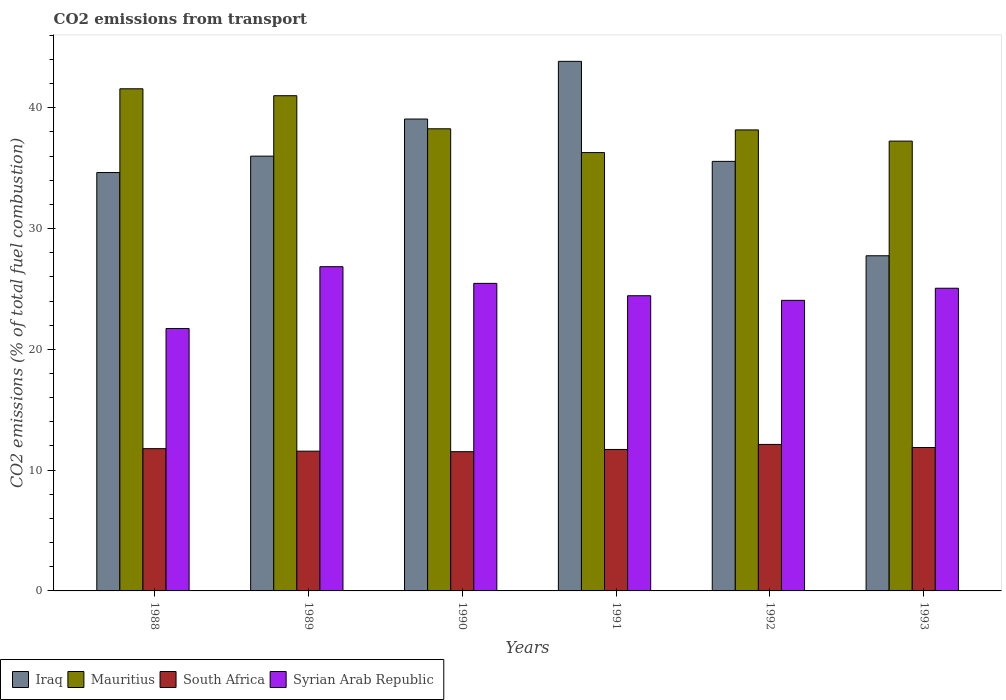How many bars are there on the 1st tick from the left?
Your answer should be very brief. 4. How many bars are there on the 2nd tick from the right?
Make the answer very short. 4. In how many cases, is the number of bars for a given year not equal to the number of legend labels?
Keep it short and to the point. 0. What is the total CO2 emitted in Mauritius in 1992?
Offer a very short reply. 38.17. Across all years, what is the maximum total CO2 emitted in Syrian Arab Republic?
Keep it short and to the point. 26.84. Across all years, what is the minimum total CO2 emitted in South Africa?
Your response must be concise. 11.53. What is the total total CO2 emitted in Iraq in the graph?
Offer a very short reply. 216.86. What is the difference between the total CO2 emitted in Mauritius in 1990 and that in 1991?
Keep it short and to the point. 1.97. What is the difference between the total CO2 emitted in Syrian Arab Republic in 1988 and the total CO2 emitted in Iraq in 1993?
Make the answer very short. -6.02. What is the average total CO2 emitted in Mauritius per year?
Your response must be concise. 38.76. In the year 1993, what is the difference between the total CO2 emitted in Mauritius and total CO2 emitted in South Africa?
Your response must be concise. 25.37. In how many years, is the total CO2 emitted in Mauritius greater than 30?
Make the answer very short. 6. What is the ratio of the total CO2 emitted in South Africa in 1989 to that in 1990?
Your answer should be compact. 1. Is the total CO2 emitted in Syrian Arab Republic in 1989 less than that in 1990?
Ensure brevity in your answer.  No. What is the difference between the highest and the second highest total CO2 emitted in Iraq?
Give a very brief answer. 4.78. What is the difference between the highest and the lowest total CO2 emitted in Iraq?
Your answer should be compact. 16.1. In how many years, is the total CO2 emitted in South Africa greater than the average total CO2 emitted in South Africa taken over all years?
Provide a short and direct response. 3. Is the sum of the total CO2 emitted in Mauritius in 1990 and 1991 greater than the maximum total CO2 emitted in Syrian Arab Republic across all years?
Offer a very short reply. Yes. What does the 4th bar from the left in 1988 represents?
Offer a terse response. Syrian Arab Republic. What does the 3rd bar from the right in 1991 represents?
Offer a terse response. Mauritius. Is it the case that in every year, the sum of the total CO2 emitted in South Africa and total CO2 emitted in Syrian Arab Republic is greater than the total CO2 emitted in Iraq?
Offer a very short reply. No. How many bars are there?
Your response must be concise. 24. How many years are there in the graph?
Offer a terse response. 6. What is the difference between two consecutive major ticks on the Y-axis?
Your answer should be compact. 10. Does the graph contain grids?
Keep it short and to the point. No. How many legend labels are there?
Give a very brief answer. 4. What is the title of the graph?
Your response must be concise. CO2 emissions from transport. What is the label or title of the Y-axis?
Provide a short and direct response. CO2 emissions (% of total fuel combustion). What is the CO2 emissions (% of total fuel combustion) of Iraq in 1988?
Your response must be concise. 34.64. What is the CO2 emissions (% of total fuel combustion) in Mauritius in 1988?
Your answer should be very brief. 41.57. What is the CO2 emissions (% of total fuel combustion) of South Africa in 1988?
Your answer should be compact. 11.78. What is the CO2 emissions (% of total fuel combustion) in Syrian Arab Republic in 1988?
Give a very brief answer. 21.73. What is the CO2 emissions (% of total fuel combustion) of Iraq in 1989?
Ensure brevity in your answer.  36. What is the CO2 emissions (% of total fuel combustion) in Mauritius in 1989?
Provide a succinct answer. 41. What is the CO2 emissions (% of total fuel combustion) of South Africa in 1989?
Keep it short and to the point. 11.57. What is the CO2 emissions (% of total fuel combustion) of Syrian Arab Republic in 1989?
Your answer should be compact. 26.84. What is the CO2 emissions (% of total fuel combustion) of Iraq in 1990?
Your answer should be compact. 39.07. What is the CO2 emissions (% of total fuel combustion) in Mauritius in 1990?
Provide a succinct answer. 38.26. What is the CO2 emissions (% of total fuel combustion) in South Africa in 1990?
Give a very brief answer. 11.53. What is the CO2 emissions (% of total fuel combustion) in Syrian Arab Republic in 1990?
Provide a succinct answer. 25.46. What is the CO2 emissions (% of total fuel combustion) in Iraq in 1991?
Your response must be concise. 43.84. What is the CO2 emissions (% of total fuel combustion) of Mauritius in 1991?
Offer a very short reply. 36.29. What is the CO2 emissions (% of total fuel combustion) in South Africa in 1991?
Provide a succinct answer. 11.71. What is the CO2 emissions (% of total fuel combustion) in Syrian Arab Republic in 1991?
Your response must be concise. 24.44. What is the CO2 emissions (% of total fuel combustion) in Iraq in 1992?
Make the answer very short. 35.56. What is the CO2 emissions (% of total fuel combustion) of Mauritius in 1992?
Your answer should be very brief. 38.17. What is the CO2 emissions (% of total fuel combustion) in South Africa in 1992?
Offer a very short reply. 12.13. What is the CO2 emissions (% of total fuel combustion) of Syrian Arab Republic in 1992?
Your answer should be compact. 24.06. What is the CO2 emissions (% of total fuel combustion) in Iraq in 1993?
Make the answer very short. 27.75. What is the CO2 emissions (% of total fuel combustion) in Mauritius in 1993?
Your answer should be compact. 37.24. What is the CO2 emissions (% of total fuel combustion) in South Africa in 1993?
Ensure brevity in your answer.  11.87. What is the CO2 emissions (% of total fuel combustion) in Syrian Arab Republic in 1993?
Make the answer very short. 25.06. Across all years, what is the maximum CO2 emissions (% of total fuel combustion) in Iraq?
Provide a succinct answer. 43.84. Across all years, what is the maximum CO2 emissions (% of total fuel combustion) of Mauritius?
Provide a short and direct response. 41.57. Across all years, what is the maximum CO2 emissions (% of total fuel combustion) in South Africa?
Offer a very short reply. 12.13. Across all years, what is the maximum CO2 emissions (% of total fuel combustion) of Syrian Arab Republic?
Your response must be concise. 26.84. Across all years, what is the minimum CO2 emissions (% of total fuel combustion) of Iraq?
Your response must be concise. 27.75. Across all years, what is the minimum CO2 emissions (% of total fuel combustion) of Mauritius?
Offer a terse response. 36.29. Across all years, what is the minimum CO2 emissions (% of total fuel combustion) in South Africa?
Offer a very short reply. 11.53. Across all years, what is the minimum CO2 emissions (% of total fuel combustion) of Syrian Arab Republic?
Provide a short and direct response. 21.73. What is the total CO2 emissions (% of total fuel combustion) of Iraq in the graph?
Your response must be concise. 216.86. What is the total CO2 emissions (% of total fuel combustion) of Mauritius in the graph?
Offer a very short reply. 232.53. What is the total CO2 emissions (% of total fuel combustion) of South Africa in the graph?
Your answer should be very brief. 70.59. What is the total CO2 emissions (% of total fuel combustion) in Syrian Arab Republic in the graph?
Offer a very short reply. 147.59. What is the difference between the CO2 emissions (% of total fuel combustion) of Iraq in 1988 and that in 1989?
Keep it short and to the point. -1.36. What is the difference between the CO2 emissions (% of total fuel combustion) in Mauritius in 1988 and that in 1989?
Your response must be concise. 0.57. What is the difference between the CO2 emissions (% of total fuel combustion) in South Africa in 1988 and that in 1989?
Give a very brief answer. 0.21. What is the difference between the CO2 emissions (% of total fuel combustion) in Syrian Arab Republic in 1988 and that in 1989?
Make the answer very short. -5.12. What is the difference between the CO2 emissions (% of total fuel combustion) in Iraq in 1988 and that in 1990?
Your response must be concise. -4.43. What is the difference between the CO2 emissions (% of total fuel combustion) of Mauritius in 1988 and that in 1990?
Give a very brief answer. 3.31. What is the difference between the CO2 emissions (% of total fuel combustion) of South Africa in 1988 and that in 1990?
Keep it short and to the point. 0.25. What is the difference between the CO2 emissions (% of total fuel combustion) in Syrian Arab Republic in 1988 and that in 1990?
Make the answer very short. -3.74. What is the difference between the CO2 emissions (% of total fuel combustion) in Iraq in 1988 and that in 1991?
Your answer should be very brief. -9.2. What is the difference between the CO2 emissions (% of total fuel combustion) of Mauritius in 1988 and that in 1991?
Your answer should be compact. 5.28. What is the difference between the CO2 emissions (% of total fuel combustion) in South Africa in 1988 and that in 1991?
Provide a short and direct response. 0.07. What is the difference between the CO2 emissions (% of total fuel combustion) in Syrian Arab Republic in 1988 and that in 1991?
Ensure brevity in your answer.  -2.71. What is the difference between the CO2 emissions (% of total fuel combustion) in Iraq in 1988 and that in 1992?
Ensure brevity in your answer.  -0.92. What is the difference between the CO2 emissions (% of total fuel combustion) in Mauritius in 1988 and that in 1992?
Keep it short and to the point. 3.41. What is the difference between the CO2 emissions (% of total fuel combustion) of South Africa in 1988 and that in 1992?
Provide a succinct answer. -0.35. What is the difference between the CO2 emissions (% of total fuel combustion) in Syrian Arab Republic in 1988 and that in 1992?
Offer a very short reply. -2.33. What is the difference between the CO2 emissions (% of total fuel combustion) of Iraq in 1988 and that in 1993?
Your answer should be very brief. 6.89. What is the difference between the CO2 emissions (% of total fuel combustion) in Mauritius in 1988 and that in 1993?
Give a very brief answer. 4.33. What is the difference between the CO2 emissions (% of total fuel combustion) of South Africa in 1988 and that in 1993?
Your response must be concise. -0.09. What is the difference between the CO2 emissions (% of total fuel combustion) of Syrian Arab Republic in 1988 and that in 1993?
Provide a short and direct response. -3.33. What is the difference between the CO2 emissions (% of total fuel combustion) of Iraq in 1989 and that in 1990?
Your response must be concise. -3.07. What is the difference between the CO2 emissions (% of total fuel combustion) of Mauritius in 1989 and that in 1990?
Your answer should be compact. 2.74. What is the difference between the CO2 emissions (% of total fuel combustion) of South Africa in 1989 and that in 1990?
Your answer should be very brief. 0.04. What is the difference between the CO2 emissions (% of total fuel combustion) in Syrian Arab Republic in 1989 and that in 1990?
Your answer should be very brief. 1.38. What is the difference between the CO2 emissions (% of total fuel combustion) of Iraq in 1989 and that in 1991?
Ensure brevity in your answer.  -7.85. What is the difference between the CO2 emissions (% of total fuel combustion) of Mauritius in 1989 and that in 1991?
Offer a very short reply. 4.71. What is the difference between the CO2 emissions (% of total fuel combustion) of South Africa in 1989 and that in 1991?
Your answer should be very brief. -0.14. What is the difference between the CO2 emissions (% of total fuel combustion) in Syrian Arab Republic in 1989 and that in 1991?
Provide a succinct answer. 2.4. What is the difference between the CO2 emissions (% of total fuel combustion) of Iraq in 1989 and that in 1992?
Provide a succinct answer. 0.43. What is the difference between the CO2 emissions (% of total fuel combustion) of Mauritius in 1989 and that in 1992?
Offer a terse response. 2.83. What is the difference between the CO2 emissions (% of total fuel combustion) in South Africa in 1989 and that in 1992?
Ensure brevity in your answer.  -0.56. What is the difference between the CO2 emissions (% of total fuel combustion) in Syrian Arab Republic in 1989 and that in 1992?
Your answer should be compact. 2.79. What is the difference between the CO2 emissions (% of total fuel combustion) of Iraq in 1989 and that in 1993?
Provide a short and direct response. 8.25. What is the difference between the CO2 emissions (% of total fuel combustion) in Mauritius in 1989 and that in 1993?
Provide a short and direct response. 3.76. What is the difference between the CO2 emissions (% of total fuel combustion) of South Africa in 1989 and that in 1993?
Offer a terse response. -0.3. What is the difference between the CO2 emissions (% of total fuel combustion) of Syrian Arab Republic in 1989 and that in 1993?
Ensure brevity in your answer.  1.78. What is the difference between the CO2 emissions (% of total fuel combustion) of Iraq in 1990 and that in 1991?
Give a very brief answer. -4.78. What is the difference between the CO2 emissions (% of total fuel combustion) of Mauritius in 1990 and that in 1991?
Provide a short and direct response. 1.97. What is the difference between the CO2 emissions (% of total fuel combustion) of South Africa in 1990 and that in 1991?
Give a very brief answer. -0.18. What is the difference between the CO2 emissions (% of total fuel combustion) in Syrian Arab Republic in 1990 and that in 1991?
Give a very brief answer. 1.02. What is the difference between the CO2 emissions (% of total fuel combustion) in Iraq in 1990 and that in 1992?
Your answer should be compact. 3.5. What is the difference between the CO2 emissions (% of total fuel combustion) in Mauritius in 1990 and that in 1992?
Offer a terse response. 0.09. What is the difference between the CO2 emissions (% of total fuel combustion) in South Africa in 1990 and that in 1992?
Keep it short and to the point. -0.6. What is the difference between the CO2 emissions (% of total fuel combustion) in Syrian Arab Republic in 1990 and that in 1992?
Offer a very short reply. 1.4. What is the difference between the CO2 emissions (% of total fuel combustion) in Iraq in 1990 and that in 1993?
Your response must be concise. 11.32. What is the difference between the CO2 emissions (% of total fuel combustion) in Mauritius in 1990 and that in 1993?
Keep it short and to the point. 1.02. What is the difference between the CO2 emissions (% of total fuel combustion) of South Africa in 1990 and that in 1993?
Make the answer very short. -0.35. What is the difference between the CO2 emissions (% of total fuel combustion) in Syrian Arab Republic in 1990 and that in 1993?
Offer a terse response. 0.4. What is the difference between the CO2 emissions (% of total fuel combustion) in Iraq in 1991 and that in 1992?
Provide a short and direct response. 8.28. What is the difference between the CO2 emissions (% of total fuel combustion) in Mauritius in 1991 and that in 1992?
Your answer should be compact. -1.88. What is the difference between the CO2 emissions (% of total fuel combustion) in South Africa in 1991 and that in 1992?
Your answer should be very brief. -0.42. What is the difference between the CO2 emissions (% of total fuel combustion) in Syrian Arab Republic in 1991 and that in 1992?
Offer a very short reply. 0.38. What is the difference between the CO2 emissions (% of total fuel combustion) of Iraq in 1991 and that in 1993?
Ensure brevity in your answer.  16.1. What is the difference between the CO2 emissions (% of total fuel combustion) of Mauritius in 1991 and that in 1993?
Keep it short and to the point. -0.95. What is the difference between the CO2 emissions (% of total fuel combustion) in South Africa in 1991 and that in 1993?
Provide a short and direct response. -0.16. What is the difference between the CO2 emissions (% of total fuel combustion) of Syrian Arab Republic in 1991 and that in 1993?
Provide a short and direct response. -0.62. What is the difference between the CO2 emissions (% of total fuel combustion) in Iraq in 1992 and that in 1993?
Your answer should be very brief. 7.82. What is the difference between the CO2 emissions (% of total fuel combustion) in Mauritius in 1992 and that in 1993?
Give a very brief answer. 0.93. What is the difference between the CO2 emissions (% of total fuel combustion) in South Africa in 1992 and that in 1993?
Provide a succinct answer. 0.25. What is the difference between the CO2 emissions (% of total fuel combustion) of Syrian Arab Republic in 1992 and that in 1993?
Your answer should be very brief. -1. What is the difference between the CO2 emissions (% of total fuel combustion) of Iraq in 1988 and the CO2 emissions (% of total fuel combustion) of Mauritius in 1989?
Give a very brief answer. -6.36. What is the difference between the CO2 emissions (% of total fuel combustion) of Iraq in 1988 and the CO2 emissions (% of total fuel combustion) of South Africa in 1989?
Make the answer very short. 23.07. What is the difference between the CO2 emissions (% of total fuel combustion) in Iraq in 1988 and the CO2 emissions (% of total fuel combustion) in Syrian Arab Republic in 1989?
Your answer should be compact. 7.8. What is the difference between the CO2 emissions (% of total fuel combustion) of Mauritius in 1988 and the CO2 emissions (% of total fuel combustion) of South Africa in 1989?
Offer a terse response. 30. What is the difference between the CO2 emissions (% of total fuel combustion) of Mauritius in 1988 and the CO2 emissions (% of total fuel combustion) of Syrian Arab Republic in 1989?
Your answer should be compact. 14.73. What is the difference between the CO2 emissions (% of total fuel combustion) in South Africa in 1988 and the CO2 emissions (% of total fuel combustion) in Syrian Arab Republic in 1989?
Offer a terse response. -15.06. What is the difference between the CO2 emissions (% of total fuel combustion) of Iraq in 1988 and the CO2 emissions (% of total fuel combustion) of Mauritius in 1990?
Provide a succinct answer. -3.62. What is the difference between the CO2 emissions (% of total fuel combustion) of Iraq in 1988 and the CO2 emissions (% of total fuel combustion) of South Africa in 1990?
Offer a terse response. 23.11. What is the difference between the CO2 emissions (% of total fuel combustion) in Iraq in 1988 and the CO2 emissions (% of total fuel combustion) in Syrian Arab Republic in 1990?
Your response must be concise. 9.18. What is the difference between the CO2 emissions (% of total fuel combustion) of Mauritius in 1988 and the CO2 emissions (% of total fuel combustion) of South Africa in 1990?
Make the answer very short. 30.05. What is the difference between the CO2 emissions (% of total fuel combustion) in Mauritius in 1988 and the CO2 emissions (% of total fuel combustion) in Syrian Arab Republic in 1990?
Offer a terse response. 16.11. What is the difference between the CO2 emissions (% of total fuel combustion) of South Africa in 1988 and the CO2 emissions (% of total fuel combustion) of Syrian Arab Republic in 1990?
Give a very brief answer. -13.68. What is the difference between the CO2 emissions (% of total fuel combustion) in Iraq in 1988 and the CO2 emissions (% of total fuel combustion) in Mauritius in 1991?
Make the answer very short. -1.65. What is the difference between the CO2 emissions (% of total fuel combustion) in Iraq in 1988 and the CO2 emissions (% of total fuel combustion) in South Africa in 1991?
Offer a very short reply. 22.93. What is the difference between the CO2 emissions (% of total fuel combustion) of Iraq in 1988 and the CO2 emissions (% of total fuel combustion) of Syrian Arab Republic in 1991?
Offer a very short reply. 10.2. What is the difference between the CO2 emissions (% of total fuel combustion) in Mauritius in 1988 and the CO2 emissions (% of total fuel combustion) in South Africa in 1991?
Your response must be concise. 29.86. What is the difference between the CO2 emissions (% of total fuel combustion) of Mauritius in 1988 and the CO2 emissions (% of total fuel combustion) of Syrian Arab Republic in 1991?
Give a very brief answer. 17.13. What is the difference between the CO2 emissions (% of total fuel combustion) of South Africa in 1988 and the CO2 emissions (% of total fuel combustion) of Syrian Arab Republic in 1991?
Make the answer very short. -12.66. What is the difference between the CO2 emissions (% of total fuel combustion) in Iraq in 1988 and the CO2 emissions (% of total fuel combustion) in Mauritius in 1992?
Give a very brief answer. -3.53. What is the difference between the CO2 emissions (% of total fuel combustion) in Iraq in 1988 and the CO2 emissions (% of total fuel combustion) in South Africa in 1992?
Offer a very short reply. 22.51. What is the difference between the CO2 emissions (% of total fuel combustion) in Iraq in 1988 and the CO2 emissions (% of total fuel combustion) in Syrian Arab Republic in 1992?
Offer a very short reply. 10.58. What is the difference between the CO2 emissions (% of total fuel combustion) in Mauritius in 1988 and the CO2 emissions (% of total fuel combustion) in South Africa in 1992?
Make the answer very short. 29.44. What is the difference between the CO2 emissions (% of total fuel combustion) of Mauritius in 1988 and the CO2 emissions (% of total fuel combustion) of Syrian Arab Republic in 1992?
Keep it short and to the point. 17.52. What is the difference between the CO2 emissions (% of total fuel combustion) in South Africa in 1988 and the CO2 emissions (% of total fuel combustion) in Syrian Arab Republic in 1992?
Your answer should be very brief. -12.28. What is the difference between the CO2 emissions (% of total fuel combustion) of Iraq in 1988 and the CO2 emissions (% of total fuel combustion) of Mauritius in 1993?
Make the answer very short. -2.6. What is the difference between the CO2 emissions (% of total fuel combustion) in Iraq in 1988 and the CO2 emissions (% of total fuel combustion) in South Africa in 1993?
Give a very brief answer. 22.77. What is the difference between the CO2 emissions (% of total fuel combustion) of Iraq in 1988 and the CO2 emissions (% of total fuel combustion) of Syrian Arab Republic in 1993?
Give a very brief answer. 9.58. What is the difference between the CO2 emissions (% of total fuel combustion) in Mauritius in 1988 and the CO2 emissions (% of total fuel combustion) in South Africa in 1993?
Offer a very short reply. 29.7. What is the difference between the CO2 emissions (% of total fuel combustion) of Mauritius in 1988 and the CO2 emissions (% of total fuel combustion) of Syrian Arab Republic in 1993?
Give a very brief answer. 16.51. What is the difference between the CO2 emissions (% of total fuel combustion) of South Africa in 1988 and the CO2 emissions (% of total fuel combustion) of Syrian Arab Republic in 1993?
Offer a terse response. -13.28. What is the difference between the CO2 emissions (% of total fuel combustion) of Iraq in 1989 and the CO2 emissions (% of total fuel combustion) of Mauritius in 1990?
Your answer should be very brief. -2.27. What is the difference between the CO2 emissions (% of total fuel combustion) of Iraq in 1989 and the CO2 emissions (% of total fuel combustion) of South Africa in 1990?
Offer a terse response. 24.47. What is the difference between the CO2 emissions (% of total fuel combustion) of Iraq in 1989 and the CO2 emissions (% of total fuel combustion) of Syrian Arab Republic in 1990?
Your response must be concise. 10.53. What is the difference between the CO2 emissions (% of total fuel combustion) in Mauritius in 1989 and the CO2 emissions (% of total fuel combustion) in South Africa in 1990?
Provide a short and direct response. 29.47. What is the difference between the CO2 emissions (% of total fuel combustion) in Mauritius in 1989 and the CO2 emissions (% of total fuel combustion) in Syrian Arab Republic in 1990?
Your response must be concise. 15.54. What is the difference between the CO2 emissions (% of total fuel combustion) of South Africa in 1989 and the CO2 emissions (% of total fuel combustion) of Syrian Arab Republic in 1990?
Offer a very short reply. -13.89. What is the difference between the CO2 emissions (% of total fuel combustion) in Iraq in 1989 and the CO2 emissions (% of total fuel combustion) in Mauritius in 1991?
Provide a succinct answer. -0.29. What is the difference between the CO2 emissions (% of total fuel combustion) of Iraq in 1989 and the CO2 emissions (% of total fuel combustion) of South Africa in 1991?
Offer a very short reply. 24.28. What is the difference between the CO2 emissions (% of total fuel combustion) of Iraq in 1989 and the CO2 emissions (% of total fuel combustion) of Syrian Arab Republic in 1991?
Your response must be concise. 11.56. What is the difference between the CO2 emissions (% of total fuel combustion) in Mauritius in 1989 and the CO2 emissions (% of total fuel combustion) in South Africa in 1991?
Your response must be concise. 29.29. What is the difference between the CO2 emissions (% of total fuel combustion) in Mauritius in 1989 and the CO2 emissions (% of total fuel combustion) in Syrian Arab Republic in 1991?
Provide a succinct answer. 16.56. What is the difference between the CO2 emissions (% of total fuel combustion) of South Africa in 1989 and the CO2 emissions (% of total fuel combustion) of Syrian Arab Republic in 1991?
Give a very brief answer. -12.87. What is the difference between the CO2 emissions (% of total fuel combustion) in Iraq in 1989 and the CO2 emissions (% of total fuel combustion) in Mauritius in 1992?
Provide a short and direct response. -2.17. What is the difference between the CO2 emissions (% of total fuel combustion) in Iraq in 1989 and the CO2 emissions (% of total fuel combustion) in South Africa in 1992?
Provide a short and direct response. 23.87. What is the difference between the CO2 emissions (% of total fuel combustion) of Iraq in 1989 and the CO2 emissions (% of total fuel combustion) of Syrian Arab Republic in 1992?
Provide a succinct answer. 11.94. What is the difference between the CO2 emissions (% of total fuel combustion) of Mauritius in 1989 and the CO2 emissions (% of total fuel combustion) of South Africa in 1992?
Ensure brevity in your answer.  28.87. What is the difference between the CO2 emissions (% of total fuel combustion) in Mauritius in 1989 and the CO2 emissions (% of total fuel combustion) in Syrian Arab Republic in 1992?
Give a very brief answer. 16.94. What is the difference between the CO2 emissions (% of total fuel combustion) of South Africa in 1989 and the CO2 emissions (% of total fuel combustion) of Syrian Arab Republic in 1992?
Your answer should be very brief. -12.49. What is the difference between the CO2 emissions (% of total fuel combustion) in Iraq in 1989 and the CO2 emissions (% of total fuel combustion) in Mauritius in 1993?
Offer a very short reply. -1.25. What is the difference between the CO2 emissions (% of total fuel combustion) of Iraq in 1989 and the CO2 emissions (% of total fuel combustion) of South Africa in 1993?
Your answer should be very brief. 24.12. What is the difference between the CO2 emissions (% of total fuel combustion) in Iraq in 1989 and the CO2 emissions (% of total fuel combustion) in Syrian Arab Republic in 1993?
Provide a succinct answer. 10.94. What is the difference between the CO2 emissions (% of total fuel combustion) in Mauritius in 1989 and the CO2 emissions (% of total fuel combustion) in South Africa in 1993?
Ensure brevity in your answer.  29.13. What is the difference between the CO2 emissions (% of total fuel combustion) in Mauritius in 1989 and the CO2 emissions (% of total fuel combustion) in Syrian Arab Republic in 1993?
Ensure brevity in your answer.  15.94. What is the difference between the CO2 emissions (% of total fuel combustion) of South Africa in 1989 and the CO2 emissions (% of total fuel combustion) of Syrian Arab Republic in 1993?
Offer a very short reply. -13.49. What is the difference between the CO2 emissions (% of total fuel combustion) of Iraq in 1990 and the CO2 emissions (% of total fuel combustion) of Mauritius in 1991?
Make the answer very short. 2.78. What is the difference between the CO2 emissions (% of total fuel combustion) in Iraq in 1990 and the CO2 emissions (% of total fuel combustion) in South Africa in 1991?
Your answer should be compact. 27.36. What is the difference between the CO2 emissions (% of total fuel combustion) of Iraq in 1990 and the CO2 emissions (% of total fuel combustion) of Syrian Arab Republic in 1991?
Give a very brief answer. 14.63. What is the difference between the CO2 emissions (% of total fuel combustion) of Mauritius in 1990 and the CO2 emissions (% of total fuel combustion) of South Africa in 1991?
Make the answer very short. 26.55. What is the difference between the CO2 emissions (% of total fuel combustion) in Mauritius in 1990 and the CO2 emissions (% of total fuel combustion) in Syrian Arab Republic in 1991?
Provide a succinct answer. 13.82. What is the difference between the CO2 emissions (% of total fuel combustion) in South Africa in 1990 and the CO2 emissions (% of total fuel combustion) in Syrian Arab Republic in 1991?
Your answer should be compact. -12.91. What is the difference between the CO2 emissions (% of total fuel combustion) in Iraq in 1990 and the CO2 emissions (% of total fuel combustion) in Mauritius in 1992?
Provide a short and direct response. 0.9. What is the difference between the CO2 emissions (% of total fuel combustion) of Iraq in 1990 and the CO2 emissions (% of total fuel combustion) of South Africa in 1992?
Your response must be concise. 26.94. What is the difference between the CO2 emissions (% of total fuel combustion) in Iraq in 1990 and the CO2 emissions (% of total fuel combustion) in Syrian Arab Republic in 1992?
Ensure brevity in your answer.  15.01. What is the difference between the CO2 emissions (% of total fuel combustion) in Mauritius in 1990 and the CO2 emissions (% of total fuel combustion) in South Africa in 1992?
Offer a terse response. 26.13. What is the difference between the CO2 emissions (% of total fuel combustion) of Mauritius in 1990 and the CO2 emissions (% of total fuel combustion) of Syrian Arab Republic in 1992?
Keep it short and to the point. 14.2. What is the difference between the CO2 emissions (% of total fuel combustion) of South Africa in 1990 and the CO2 emissions (% of total fuel combustion) of Syrian Arab Republic in 1992?
Your answer should be compact. -12.53. What is the difference between the CO2 emissions (% of total fuel combustion) of Iraq in 1990 and the CO2 emissions (% of total fuel combustion) of Mauritius in 1993?
Your response must be concise. 1.83. What is the difference between the CO2 emissions (% of total fuel combustion) of Iraq in 1990 and the CO2 emissions (% of total fuel combustion) of South Africa in 1993?
Offer a very short reply. 27.19. What is the difference between the CO2 emissions (% of total fuel combustion) of Iraq in 1990 and the CO2 emissions (% of total fuel combustion) of Syrian Arab Republic in 1993?
Keep it short and to the point. 14.01. What is the difference between the CO2 emissions (% of total fuel combustion) of Mauritius in 1990 and the CO2 emissions (% of total fuel combustion) of South Africa in 1993?
Provide a succinct answer. 26.39. What is the difference between the CO2 emissions (% of total fuel combustion) of Mauritius in 1990 and the CO2 emissions (% of total fuel combustion) of Syrian Arab Republic in 1993?
Provide a succinct answer. 13.2. What is the difference between the CO2 emissions (% of total fuel combustion) in South Africa in 1990 and the CO2 emissions (% of total fuel combustion) in Syrian Arab Republic in 1993?
Your answer should be compact. -13.53. What is the difference between the CO2 emissions (% of total fuel combustion) in Iraq in 1991 and the CO2 emissions (% of total fuel combustion) in Mauritius in 1992?
Offer a very short reply. 5.68. What is the difference between the CO2 emissions (% of total fuel combustion) in Iraq in 1991 and the CO2 emissions (% of total fuel combustion) in South Africa in 1992?
Give a very brief answer. 31.72. What is the difference between the CO2 emissions (% of total fuel combustion) of Iraq in 1991 and the CO2 emissions (% of total fuel combustion) of Syrian Arab Republic in 1992?
Provide a short and direct response. 19.79. What is the difference between the CO2 emissions (% of total fuel combustion) in Mauritius in 1991 and the CO2 emissions (% of total fuel combustion) in South Africa in 1992?
Your answer should be very brief. 24.16. What is the difference between the CO2 emissions (% of total fuel combustion) of Mauritius in 1991 and the CO2 emissions (% of total fuel combustion) of Syrian Arab Republic in 1992?
Ensure brevity in your answer.  12.23. What is the difference between the CO2 emissions (% of total fuel combustion) in South Africa in 1991 and the CO2 emissions (% of total fuel combustion) in Syrian Arab Republic in 1992?
Give a very brief answer. -12.35. What is the difference between the CO2 emissions (% of total fuel combustion) in Iraq in 1991 and the CO2 emissions (% of total fuel combustion) in Mauritius in 1993?
Offer a terse response. 6.6. What is the difference between the CO2 emissions (% of total fuel combustion) in Iraq in 1991 and the CO2 emissions (% of total fuel combustion) in South Africa in 1993?
Keep it short and to the point. 31.97. What is the difference between the CO2 emissions (% of total fuel combustion) in Iraq in 1991 and the CO2 emissions (% of total fuel combustion) in Syrian Arab Republic in 1993?
Ensure brevity in your answer.  18.79. What is the difference between the CO2 emissions (% of total fuel combustion) of Mauritius in 1991 and the CO2 emissions (% of total fuel combustion) of South Africa in 1993?
Ensure brevity in your answer.  24.42. What is the difference between the CO2 emissions (% of total fuel combustion) of Mauritius in 1991 and the CO2 emissions (% of total fuel combustion) of Syrian Arab Republic in 1993?
Provide a succinct answer. 11.23. What is the difference between the CO2 emissions (% of total fuel combustion) in South Africa in 1991 and the CO2 emissions (% of total fuel combustion) in Syrian Arab Republic in 1993?
Your response must be concise. -13.35. What is the difference between the CO2 emissions (% of total fuel combustion) in Iraq in 1992 and the CO2 emissions (% of total fuel combustion) in Mauritius in 1993?
Keep it short and to the point. -1.68. What is the difference between the CO2 emissions (% of total fuel combustion) in Iraq in 1992 and the CO2 emissions (% of total fuel combustion) in South Africa in 1993?
Keep it short and to the point. 23.69. What is the difference between the CO2 emissions (% of total fuel combustion) in Iraq in 1992 and the CO2 emissions (% of total fuel combustion) in Syrian Arab Republic in 1993?
Provide a succinct answer. 10.5. What is the difference between the CO2 emissions (% of total fuel combustion) in Mauritius in 1992 and the CO2 emissions (% of total fuel combustion) in South Africa in 1993?
Make the answer very short. 26.29. What is the difference between the CO2 emissions (% of total fuel combustion) of Mauritius in 1992 and the CO2 emissions (% of total fuel combustion) of Syrian Arab Republic in 1993?
Keep it short and to the point. 13.11. What is the difference between the CO2 emissions (% of total fuel combustion) of South Africa in 1992 and the CO2 emissions (% of total fuel combustion) of Syrian Arab Republic in 1993?
Provide a short and direct response. -12.93. What is the average CO2 emissions (% of total fuel combustion) of Iraq per year?
Provide a short and direct response. 36.14. What is the average CO2 emissions (% of total fuel combustion) in Mauritius per year?
Make the answer very short. 38.76. What is the average CO2 emissions (% of total fuel combustion) in South Africa per year?
Offer a very short reply. 11.77. What is the average CO2 emissions (% of total fuel combustion) of Syrian Arab Republic per year?
Offer a terse response. 24.6. In the year 1988, what is the difference between the CO2 emissions (% of total fuel combustion) of Iraq and CO2 emissions (% of total fuel combustion) of Mauritius?
Your answer should be very brief. -6.93. In the year 1988, what is the difference between the CO2 emissions (% of total fuel combustion) of Iraq and CO2 emissions (% of total fuel combustion) of South Africa?
Your answer should be compact. 22.86. In the year 1988, what is the difference between the CO2 emissions (% of total fuel combustion) of Iraq and CO2 emissions (% of total fuel combustion) of Syrian Arab Republic?
Your answer should be very brief. 12.91. In the year 1988, what is the difference between the CO2 emissions (% of total fuel combustion) of Mauritius and CO2 emissions (% of total fuel combustion) of South Africa?
Offer a terse response. 29.79. In the year 1988, what is the difference between the CO2 emissions (% of total fuel combustion) of Mauritius and CO2 emissions (% of total fuel combustion) of Syrian Arab Republic?
Make the answer very short. 19.85. In the year 1988, what is the difference between the CO2 emissions (% of total fuel combustion) of South Africa and CO2 emissions (% of total fuel combustion) of Syrian Arab Republic?
Provide a short and direct response. -9.95. In the year 1989, what is the difference between the CO2 emissions (% of total fuel combustion) in Iraq and CO2 emissions (% of total fuel combustion) in Mauritius?
Make the answer very short. -5. In the year 1989, what is the difference between the CO2 emissions (% of total fuel combustion) in Iraq and CO2 emissions (% of total fuel combustion) in South Africa?
Provide a succinct answer. 24.42. In the year 1989, what is the difference between the CO2 emissions (% of total fuel combustion) in Iraq and CO2 emissions (% of total fuel combustion) in Syrian Arab Republic?
Ensure brevity in your answer.  9.15. In the year 1989, what is the difference between the CO2 emissions (% of total fuel combustion) in Mauritius and CO2 emissions (% of total fuel combustion) in South Africa?
Make the answer very short. 29.43. In the year 1989, what is the difference between the CO2 emissions (% of total fuel combustion) in Mauritius and CO2 emissions (% of total fuel combustion) in Syrian Arab Republic?
Give a very brief answer. 14.16. In the year 1989, what is the difference between the CO2 emissions (% of total fuel combustion) of South Africa and CO2 emissions (% of total fuel combustion) of Syrian Arab Republic?
Offer a terse response. -15.27. In the year 1990, what is the difference between the CO2 emissions (% of total fuel combustion) of Iraq and CO2 emissions (% of total fuel combustion) of Mauritius?
Give a very brief answer. 0.81. In the year 1990, what is the difference between the CO2 emissions (% of total fuel combustion) of Iraq and CO2 emissions (% of total fuel combustion) of South Africa?
Offer a very short reply. 27.54. In the year 1990, what is the difference between the CO2 emissions (% of total fuel combustion) in Iraq and CO2 emissions (% of total fuel combustion) in Syrian Arab Republic?
Your response must be concise. 13.61. In the year 1990, what is the difference between the CO2 emissions (% of total fuel combustion) of Mauritius and CO2 emissions (% of total fuel combustion) of South Africa?
Your response must be concise. 26.73. In the year 1990, what is the difference between the CO2 emissions (% of total fuel combustion) of Mauritius and CO2 emissions (% of total fuel combustion) of Syrian Arab Republic?
Keep it short and to the point. 12.8. In the year 1990, what is the difference between the CO2 emissions (% of total fuel combustion) of South Africa and CO2 emissions (% of total fuel combustion) of Syrian Arab Republic?
Offer a terse response. -13.93. In the year 1991, what is the difference between the CO2 emissions (% of total fuel combustion) in Iraq and CO2 emissions (% of total fuel combustion) in Mauritius?
Offer a terse response. 7.55. In the year 1991, what is the difference between the CO2 emissions (% of total fuel combustion) of Iraq and CO2 emissions (% of total fuel combustion) of South Africa?
Ensure brevity in your answer.  32.13. In the year 1991, what is the difference between the CO2 emissions (% of total fuel combustion) in Iraq and CO2 emissions (% of total fuel combustion) in Syrian Arab Republic?
Your answer should be very brief. 19.4. In the year 1991, what is the difference between the CO2 emissions (% of total fuel combustion) of Mauritius and CO2 emissions (% of total fuel combustion) of South Africa?
Offer a terse response. 24.58. In the year 1991, what is the difference between the CO2 emissions (% of total fuel combustion) in Mauritius and CO2 emissions (% of total fuel combustion) in Syrian Arab Republic?
Give a very brief answer. 11.85. In the year 1991, what is the difference between the CO2 emissions (% of total fuel combustion) of South Africa and CO2 emissions (% of total fuel combustion) of Syrian Arab Republic?
Offer a terse response. -12.73. In the year 1992, what is the difference between the CO2 emissions (% of total fuel combustion) of Iraq and CO2 emissions (% of total fuel combustion) of Mauritius?
Ensure brevity in your answer.  -2.6. In the year 1992, what is the difference between the CO2 emissions (% of total fuel combustion) of Iraq and CO2 emissions (% of total fuel combustion) of South Africa?
Offer a terse response. 23.44. In the year 1992, what is the difference between the CO2 emissions (% of total fuel combustion) of Iraq and CO2 emissions (% of total fuel combustion) of Syrian Arab Republic?
Make the answer very short. 11.51. In the year 1992, what is the difference between the CO2 emissions (% of total fuel combustion) of Mauritius and CO2 emissions (% of total fuel combustion) of South Africa?
Provide a succinct answer. 26.04. In the year 1992, what is the difference between the CO2 emissions (% of total fuel combustion) in Mauritius and CO2 emissions (% of total fuel combustion) in Syrian Arab Republic?
Your answer should be very brief. 14.11. In the year 1992, what is the difference between the CO2 emissions (% of total fuel combustion) of South Africa and CO2 emissions (% of total fuel combustion) of Syrian Arab Republic?
Your answer should be compact. -11.93. In the year 1993, what is the difference between the CO2 emissions (% of total fuel combustion) of Iraq and CO2 emissions (% of total fuel combustion) of Mauritius?
Make the answer very short. -9.49. In the year 1993, what is the difference between the CO2 emissions (% of total fuel combustion) in Iraq and CO2 emissions (% of total fuel combustion) in South Africa?
Keep it short and to the point. 15.87. In the year 1993, what is the difference between the CO2 emissions (% of total fuel combustion) in Iraq and CO2 emissions (% of total fuel combustion) in Syrian Arab Republic?
Ensure brevity in your answer.  2.69. In the year 1993, what is the difference between the CO2 emissions (% of total fuel combustion) in Mauritius and CO2 emissions (% of total fuel combustion) in South Africa?
Provide a short and direct response. 25.37. In the year 1993, what is the difference between the CO2 emissions (% of total fuel combustion) of Mauritius and CO2 emissions (% of total fuel combustion) of Syrian Arab Republic?
Offer a very short reply. 12.18. In the year 1993, what is the difference between the CO2 emissions (% of total fuel combustion) in South Africa and CO2 emissions (% of total fuel combustion) in Syrian Arab Republic?
Provide a short and direct response. -13.19. What is the ratio of the CO2 emissions (% of total fuel combustion) in Iraq in 1988 to that in 1989?
Give a very brief answer. 0.96. What is the ratio of the CO2 emissions (% of total fuel combustion) in Mauritius in 1988 to that in 1989?
Ensure brevity in your answer.  1.01. What is the ratio of the CO2 emissions (% of total fuel combustion) in Syrian Arab Republic in 1988 to that in 1989?
Your response must be concise. 0.81. What is the ratio of the CO2 emissions (% of total fuel combustion) of Iraq in 1988 to that in 1990?
Offer a very short reply. 0.89. What is the ratio of the CO2 emissions (% of total fuel combustion) of Mauritius in 1988 to that in 1990?
Offer a terse response. 1.09. What is the ratio of the CO2 emissions (% of total fuel combustion) in South Africa in 1988 to that in 1990?
Keep it short and to the point. 1.02. What is the ratio of the CO2 emissions (% of total fuel combustion) in Syrian Arab Republic in 1988 to that in 1990?
Ensure brevity in your answer.  0.85. What is the ratio of the CO2 emissions (% of total fuel combustion) in Iraq in 1988 to that in 1991?
Give a very brief answer. 0.79. What is the ratio of the CO2 emissions (% of total fuel combustion) of Mauritius in 1988 to that in 1991?
Provide a succinct answer. 1.15. What is the ratio of the CO2 emissions (% of total fuel combustion) of Syrian Arab Republic in 1988 to that in 1991?
Your answer should be compact. 0.89. What is the ratio of the CO2 emissions (% of total fuel combustion) of Mauritius in 1988 to that in 1992?
Give a very brief answer. 1.09. What is the ratio of the CO2 emissions (% of total fuel combustion) in South Africa in 1988 to that in 1992?
Provide a succinct answer. 0.97. What is the ratio of the CO2 emissions (% of total fuel combustion) of Syrian Arab Republic in 1988 to that in 1992?
Give a very brief answer. 0.9. What is the ratio of the CO2 emissions (% of total fuel combustion) of Iraq in 1988 to that in 1993?
Give a very brief answer. 1.25. What is the ratio of the CO2 emissions (% of total fuel combustion) in Mauritius in 1988 to that in 1993?
Your answer should be compact. 1.12. What is the ratio of the CO2 emissions (% of total fuel combustion) of South Africa in 1988 to that in 1993?
Provide a succinct answer. 0.99. What is the ratio of the CO2 emissions (% of total fuel combustion) of Syrian Arab Republic in 1988 to that in 1993?
Your answer should be very brief. 0.87. What is the ratio of the CO2 emissions (% of total fuel combustion) of Iraq in 1989 to that in 1990?
Offer a terse response. 0.92. What is the ratio of the CO2 emissions (% of total fuel combustion) in Mauritius in 1989 to that in 1990?
Offer a terse response. 1.07. What is the ratio of the CO2 emissions (% of total fuel combustion) of Syrian Arab Republic in 1989 to that in 1990?
Give a very brief answer. 1.05. What is the ratio of the CO2 emissions (% of total fuel combustion) of Iraq in 1989 to that in 1991?
Provide a succinct answer. 0.82. What is the ratio of the CO2 emissions (% of total fuel combustion) of Mauritius in 1989 to that in 1991?
Provide a succinct answer. 1.13. What is the ratio of the CO2 emissions (% of total fuel combustion) of South Africa in 1989 to that in 1991?
Make the answer very short. 0.99. What is the ratio of the CO2 emissions (% of total fuel combustion) in Syrian Arab Republic in 1989 to that in 1991?
Your response must be concise. 1.1. What is the ratio of the CO2 emissions (% of total fuel combustion) of Iraq in 1989 to that in 1992?
Offer a very short reply. 1.01. What is the ratio of the CO2 emissions (% of total fuel combustion) in Mauritius in 1989 to that in 1992?
Make the answer very short. 1.07. What is the ratio of the CO2 emissions (% of total fuel combustion) of South Africa in 1989 to that in 1992?
Provide a succinct answer. 0.95. What is the ratio of the CO2 emissions (% of total fuel combustion) of Syrian Arab Republic in 1989 to that in 1992?
Provide a short and direct response. 1.12. What is the ratio of the CO2 emissions (% of total fuel combustion) in Iraq in 1989 to that in 1993?
Your response must be concise. 1.3. What is the ratio of the CO2 emissions (% of total fuel combustion) of Mauritius in 1989 to that in 1993?
Offer a terse response. 1.1. What is the ratio of the CO2 emissions (% of total fuel combustion) of South Africa in 1989 to that in 1993?
Offer a very short reply. 0.97. What is the ratio of the CO2 emissions (% of total fuel combustion) in Syrian Arab Republic in 1989 to that in 1993?
Offer a very short reply. 1.07. What is the ratio of the CO2 emissions (% of total fuel combustion) of Iraq in 1990 to that in 1991?
Keep it short and to the point. 0.89. What is the ratio of the CO2 emissions (% of total fuel combustion) of Mauritius in 1990 to that in 1991?
Your response must be concise. 1.05. What is the ratio of the CO2 emissions (% of total fuel combustion) of South Africa in 1990 to that in 1991?
Ensure brevity in your answer.  0.98. What is the ratio of the CO2 emissions (% of total fuel combustion) in Syrian Arab Republic in 1990 to that in 1991?
Keep it short and to the point. 1.04. What is the ratio of the CO2 emissions (% of total fuel combustion) of Iraq in 1990 to that in 1992?
Provide a succinct answer. 1.1. What is the ratio of the CO2 emissions (% of total fuel combustion) of South Africa in 1990 to that in 1992?
Your response must be concise. 0.95. What is the ratio of the CO2 emissions (% of total fuel combustion) in Syrian Arab Republic in 1990 to that in 1992?
Offer a very short reply. 1.06. What is the ratio of the CO2 emissions (% of total fuel combustion) in Iraq in 1990 to that in 1993?
Your answer should be compact. 1.41. What is the ratio of the CO2 emissions (% of total fuel combustion) of Mauritius in 1990 to that in 1993?
Make the answer very short. 1.03. What is the ratio of the CO2 emissions (% of total fuel combustion) in South Africa in 1990 to that in 1993?
Your response must be concise. 0.97. What is the ratio of the CO2 emissions (% of total fuel combustion) of Syrian Arab Republic in 1990 to that in 1993?
Ensure brevity in your answer.  1.02. What is the ratio of the CO2 emissions (% of total fuel combustion) of Iraq in 1991 to that in 1992?
Provide a succinct answer. 1.23. What is the ratio of the CO2 emissions (% of total fuel combustion) of Mauritius in 1991 to that in 1992?
Your answer should be very brief. 0.95. What is the ratio of the CO2 emissions (% of total fuel combustion) in South Africa in 1991 to that in 1992?
Give a very brief answer. 0.97. What is the ratio of the CO2 emissions (% of total fuel combustion) in Syrian Arab Republic in 1991 to that in 1992?
Your answer should be compact. 1.02. What is the ratio of the CO2 emissions (% of total fuel combustion) in Iraq in 1991 to that in 1993?
Provide a short and direct response. 1.58. What is the ratio of the CO2 emissions (% of total fuel combustion) of Mauritius in 1991 to that in 1993?
Offer a very short reply. 0.97. What is the ratio of the CO2 emissions (% of total fuel combustion) of South Africa in 1991 to that in 1993?
Offer a terse response. 0.99. What is the ratio of the CO2 emissions (% of total fuel combustion) of Syrian Arab Republic in 1991 to that in 1993?
Give a very brief answer. 0.98. What is the ratio of the CO2 emissions (% of total fuel combustion) of Iraq in 1992 to that in 1993?
Give a very brief answer. 1.28. What is the ratio of the CO2 emissions (% of total fuel combustion) in Mauritius in 1992 to that in 1993?
Provide a succinct answer. 1.02. What is the ratio of the CO2 emissions (% of total fuel combustion) of South Africa in 1992 to that in 1993?
Offer a very short reply. 1.02. What is the difference between the highest and the second highest CO2 emissions (% of total fuel combustion) of Iraq?
Offer a terse response. 4.78. What is the difference between the highest and the second highest CO2 emissions (% of total fuel combustion) in Mauritius?
Provide a succinct answer. 0.57. What is the difference between the highest and the second highest CO2 emissions (% of total fuel combustion) of South Africa?
Provide a short and direct response. 0.25. What is the difference between the highest and the second highest CO2 emissions (% of total fuel combustion) in Syrian Arab Republic?
Offer a terse response. 1.38. What is the difference between the highest and the lowest CO2 emissions (% of total fuel combustion) of Iraq?
Make the answer very short. 16.1. What is the difference between the highest and the lowest CO2 emissions (% of total fuel combustion) of Mauritius?
Make the answer very short. 5.28. What is the difference between the highest and the lowest CO2 emissions (% of total fuel combustion) in South Africa?
Offer a very short reply. 0.6. What is the difference between the highest and the lowest CO2 emissions (% of total fuel combustion) in Syrian Arab Republic?
Your answer should be compact. 5.12. 